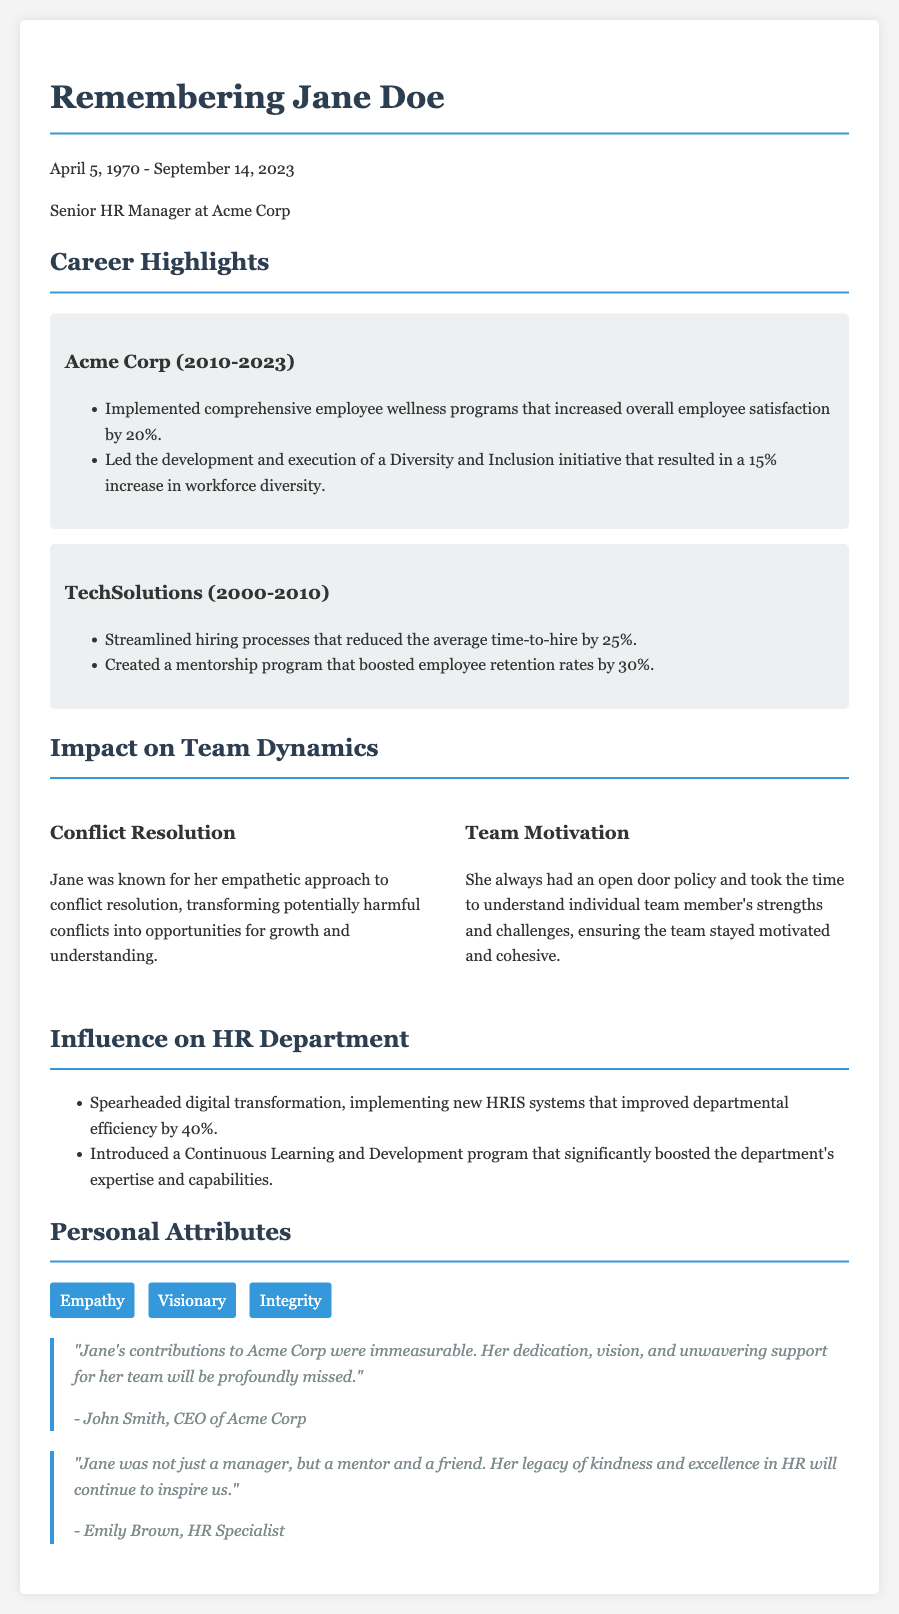What was Jane Doe's position? Jane Doe held the position of Senior HR Manager at Acme Corp, as stated in the document.
Answer: Senior HR Manager What years did Jane work at Acme Corp? The document specifies that Jane worked at Acme Corp from 2010 to 2023.
Answer: 2010-2023 How much did the employee wellness programs increase satisfaction? The document indicates that the employee wellness programs increased overall employee satisfaction by 20%.
Answer: 20% What was one of Jane's personal attributes? The document lists empathy as one of Jane's personal attributes.
Answer: Empathy How did Jane's approach to conflict resolution impact the team? Jane's empathetic approach transformed potentially harmful conflicts into opportunities for growth and understanding, affecting team dynamics positively.
Answer: Growth and understanding What percentage increase did the Diversity and Inclusion initiative achieve? The document indicates that the Diversity and Inclusion initiative resulted in a 15% increase in workforce diversity.
Answer: 15% Who is quoted praising Jane in the document? The quotes in the document come from John Smith, CEO of Acme Corp, and Emily Brown, HR Specialist.
Answer: John Smith and Emily Brown What program did Jane introduce to boost the department's expertise? The Continuous Learning and Development program was introduced by Jane to enhance the department's capabilities.
Answer: Continuous Learning and Development program 